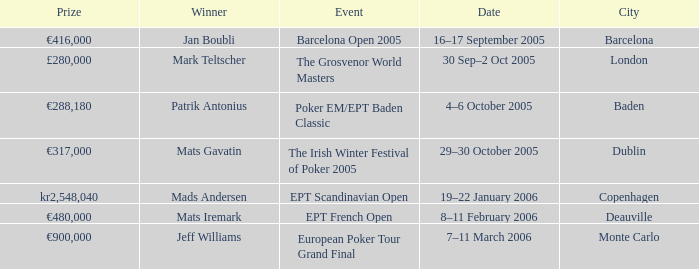What event did Mark Teltscher win? The Grosvenor World Masters. 